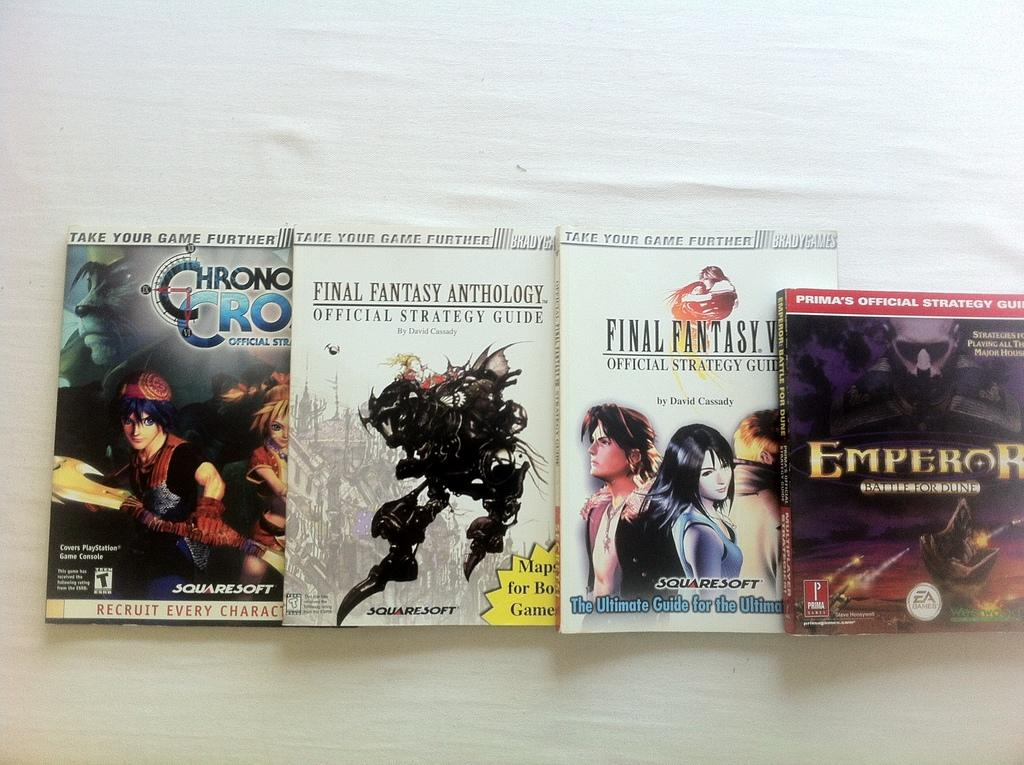What objects are present in the image? There are books in the image. What can be seen on top of the books? There is text and a cartoon image visible on top of the books. What might be the color of the surface on which the books are placed? The books might be placed on a white color table. What type of insurance policy is being advertised on the books in the image? There is no insurance policy being advertised on the books in the image; the image only features text and a cartoon image on top of the books. 